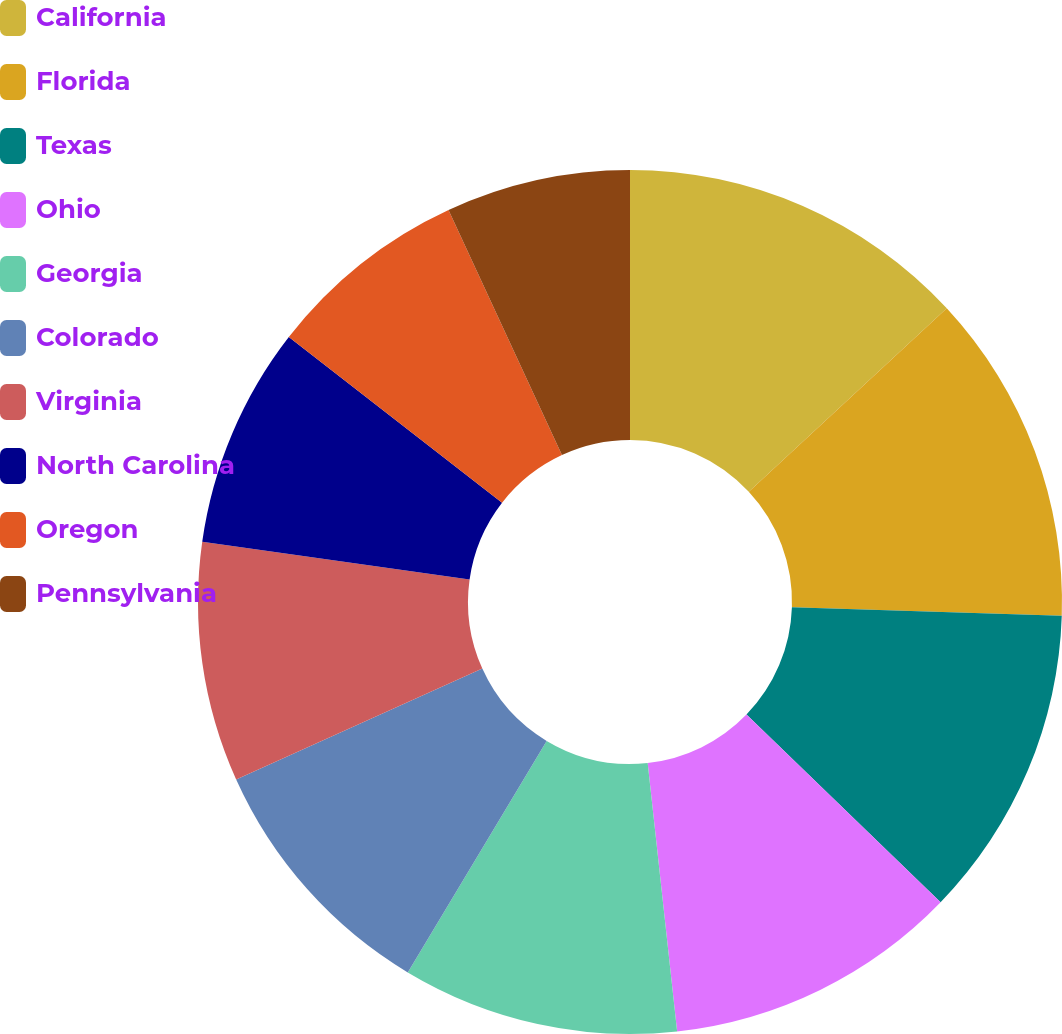Convert chart to OTSL. <chart><loc_0><loc_0><loc_500><loc_500><pie_chart><fcel>California<fcel>Florida<fcel>Texas<fcel>Ohio<fcel>Georgia<fcel>Colorado<fcel>Virginia<fcel>North Carolina<fcel>Oregon<fcel>Pennsylvania<nl><fcel>13.1%<fcel>12.41%<fcel>11.72%<fcel>11.03%<fcel>10.34%<fcel>9.66%<fcel>8.97%<fcel>8.28%<fcel>7.59%<fcel>6.9%<nl></chart> 